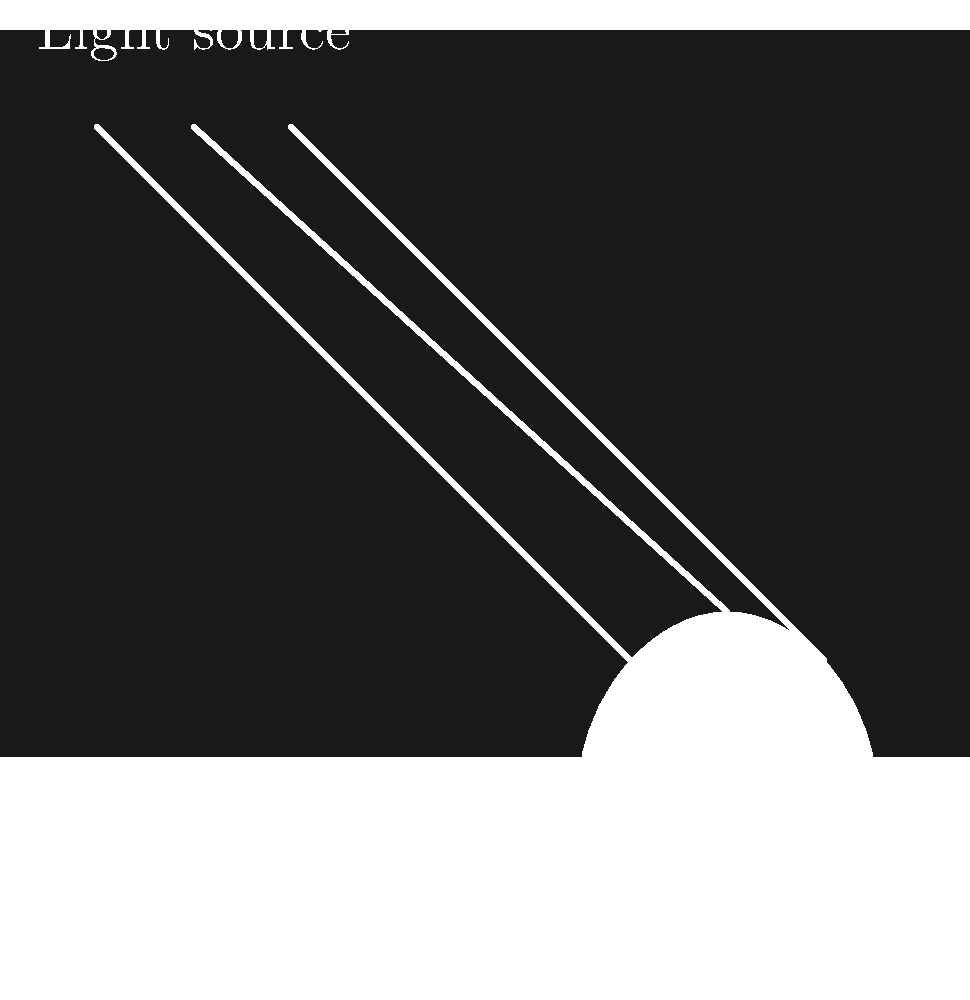In Bill Curtsinger's iconic polar bear photograph, what lighting technique is likely used to create the dramatic contrast between the bear's white fur and the dark background, while maintaining detail in both areas? To determine the lighting technique used in Bill Curtsinger's polar bear photograph, let's consider the following steps:

1. Observe the contrast: The photograph shows a stark contrast between the white polar bear and the dark background, which is typical of Arctic environments.

2. Analyze the lighting direction: The light appears to be coming from above and slightly to the side of the bear, as indicated by the highlights on its fur.

3. Consider the detail preservation: Both the bear's white fur and the dark background maintain detail, suggesting a careful balance of exposure.

4. Evaluate the environment: Arctic photography often involves challenging lighting conditions due to the reflective nature of snow and ice.

5. Identify the technique: Given these observations, the most likely technique used is fill flash. This involves using the camera's flash to "fill in" shadows while still maintaining the natural ambient light.

6. Understand the benefits: Fill flash allows the photographer to:
   a) Illuminate the subject (polar bear) without overexposing the bright areas
   b) Maintain detail in the darker background
   c) Create a more balanced exposure in high-contrast situations

7. Consider Curtsinger's expertise: As an experienced National Geographic photographer, Curtsinger is known for his mastery of underwater and polar photography techniques.

By using fill flash, Curtsinger would have been able to capture the polar bear's white fur with crisp detail while still preserving the mood and atmosphere of the Arctic environment in the background.
Answer: Fill flash 